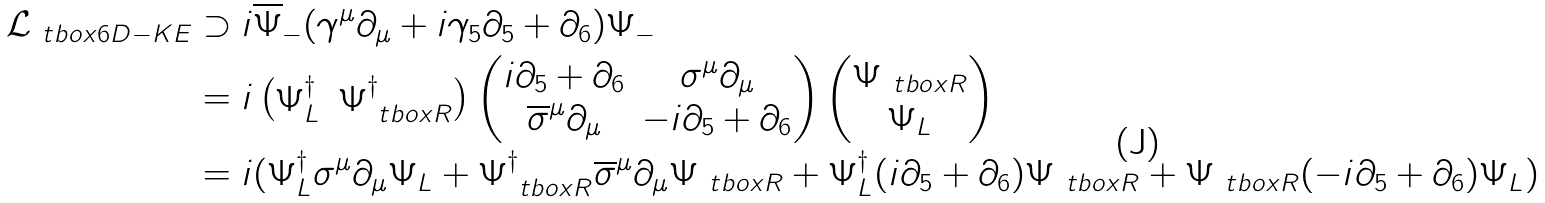Convert formula to latex. <formula><loc_0><loc_0><loc_500><loc_500>\mathcal { L } _ { \ t b o x { 6 D - K E } } & \supset i \overline { \Psi } _ { - } ( \gamma ^ { \mu } \partial _ { \mu } + i \gamma _ { 5 } \partial _ { 5 } + \partial _ { 6 } ) \Psi _ { - } \\ & = i \begin{pmatrix} \Psi ^ { \dag } _ { L } & \Psi ^ { \dag } _ { \ t b o x { R } } \end{pmatrix} \begin{pmatrix} i \partial _ { 5 } + \partial _ { 6 } & \sigma ^ { \mu } \partial _ { \mu } \\ \overline { \sigma } ^ { \mu } \partial _ { \mu } & - i \partial _ { 5 } + \partial _ { 6 } \end{pmatrix} \begin{pmatrix} \Psi _ { \ t b o x { R } } \\ \Psi _ { L } \end{pmatrix} \\ & = i ( \Psi ^ { \dag } _ { L } \sigma ^ { \mu } \partial _ { \mu } \Psi _ { L } + \Psi ^ { \dag } _ { \ t b o x { R } } \overline { \sigma } ^ { \mu } \partial _ { \mu } \Psi _ { \ t b o x { R } } + \Psi ^ { \dag } _ { L } ( i \partial _ { 5 } + \partial _ { 6 } ) \Psi _ { \ t b o x { R } } + \Psi _ { \ t b o x { R } } ( - i \partial _ { 5 } + \partial _ { 6 } ) \Psi _ { L } )</formula> 